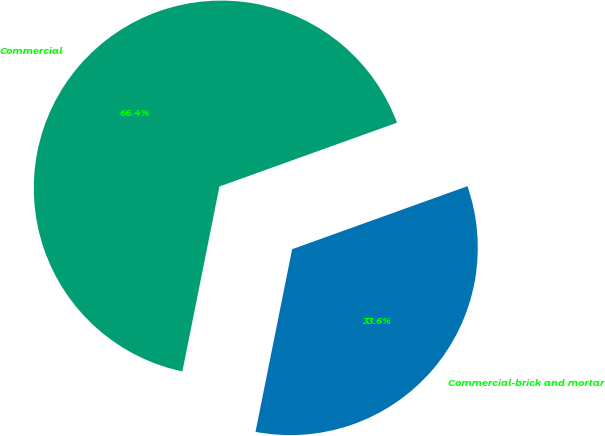<chart> <loc_0><loc_0><loc_500><loc_500><pie_chart><fcel>Commercial-brick and mortar<fcel>Commercial<nl><fcel>33.64%<fcel>66.36%<nl></chart> 